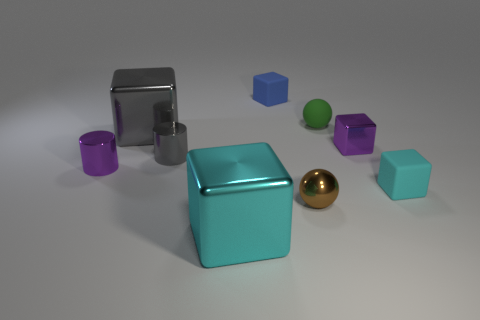Subtract all gray cubes. How many cubes are left? 4 Subtract all tiny shiny blocks. How many blocks are left? 4 Subtract all green cubes. Subtract all red cylinders. How many cubes are left? 5 Subtract all cylinders. How many objects are left? 7 Add 4 small purple metal cylinders. How many small purple metal cylinders exist? 5 Subtract 0 yellow cubes. How many objects are left? 9 Subtract all tiny cyan objects. Subtract all large red blocks. How many objects are left? 8 Add 9 large gray metal blocks. How many large gray metal blocks are left? 10 